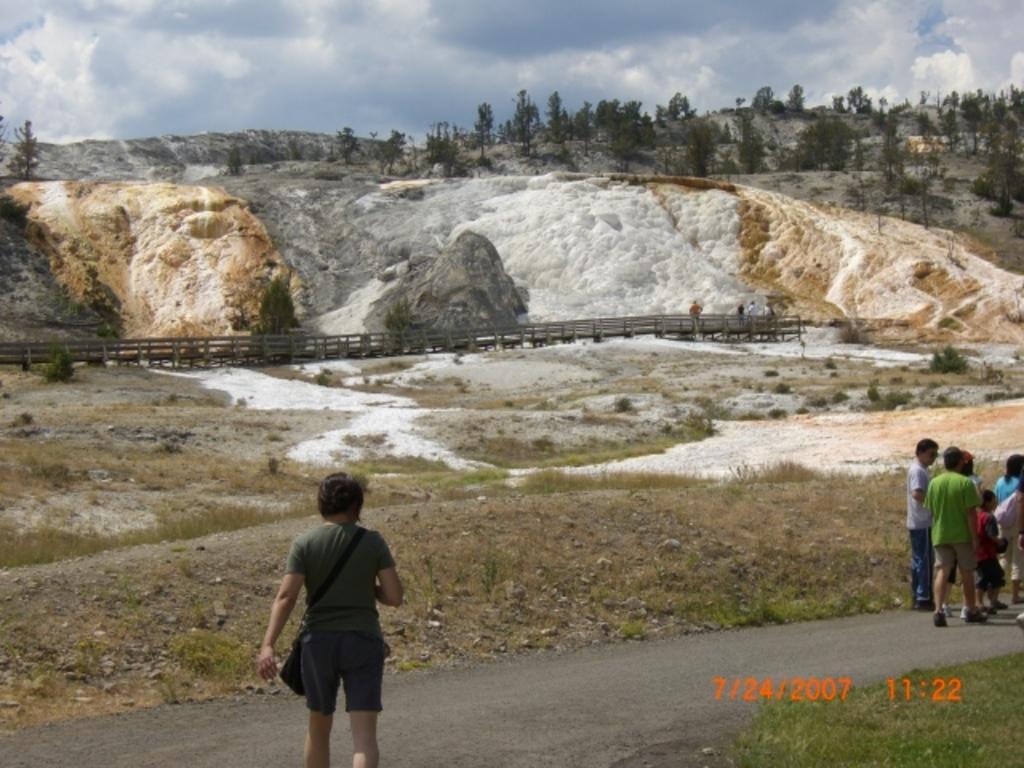How would you summarize this image in a sentence or two? In this picture we can see some people are walking and some people are standing on the walkway. Behind the people it looks like a bridge and behind the bridge there are trees, hill and the sky. On the image there is a watermark. 